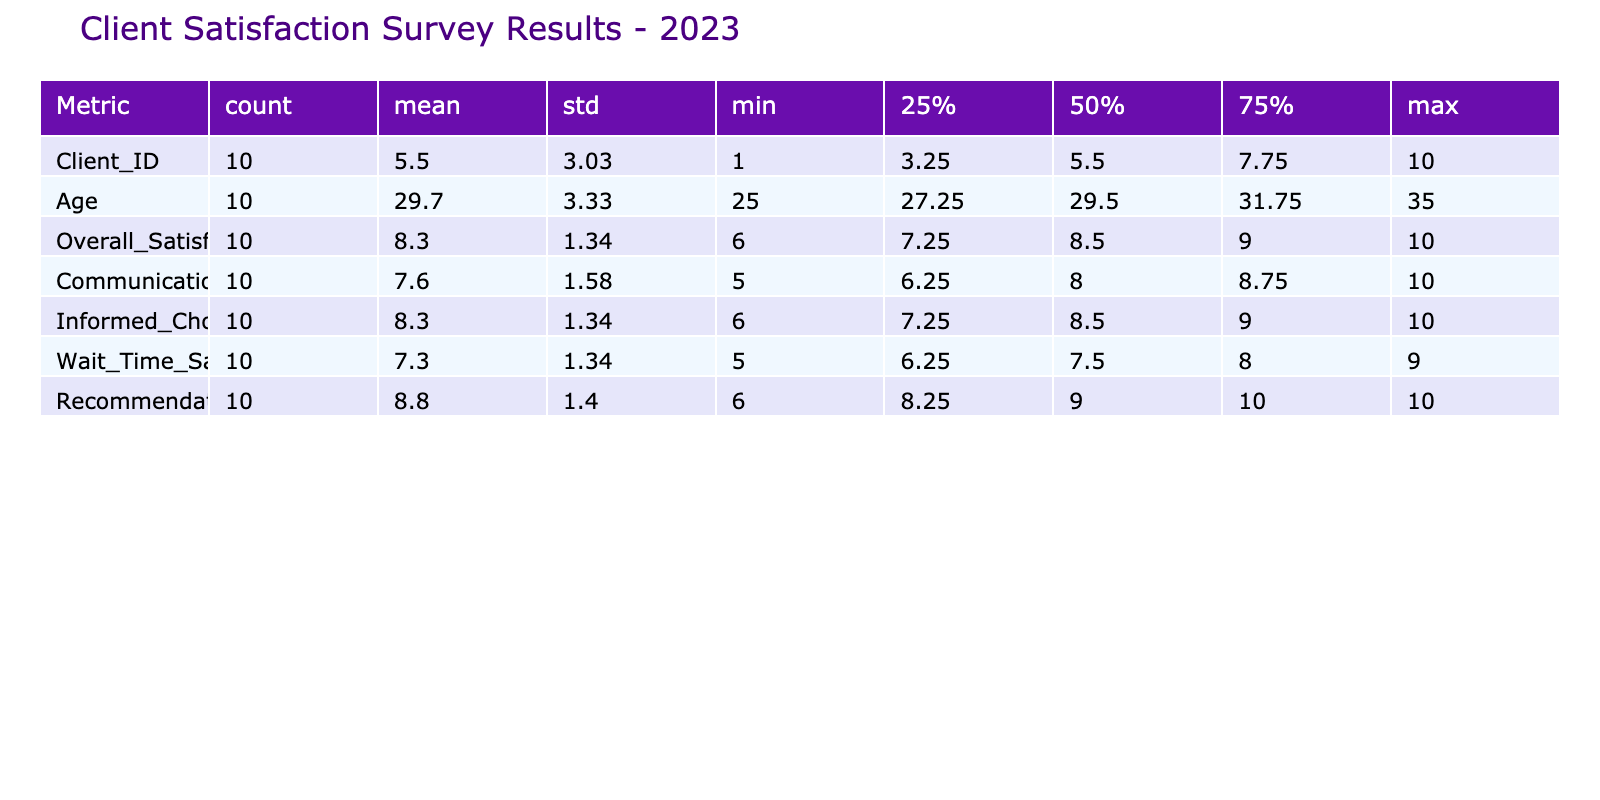What is the overall satisfaction rating for the hospital birth type of care? From the table, we can find the rows for hospital birth. The overall satisfaction ratings are 7, 8, 6, and 7 for each of the four clients who received this type of care. Among these ratings, the highest is 8, while the lowest is 6. The average can be found as (7 + 8 + 6 + 7) / 4 = 7. Thereby, the overall satisfaction rating for hospital births is 7.
Answer: 7 What is the highest communication satisfaction rating recorded in the survey? Looking at the 'Communication Satisfaction' column, the ratings are 8, 6, 9, 7, 8, 9, 5, 10, 8, and 6. The highest rating is 10, which is associated with the client who had a freestanding birth center.
Answer: 10 Can we say that everyone who utilized home birth care would recommend it? By examining the 'Recommendation Likelihood' column for home birth clients, the ratings are 10, 10, 9, 8, and 9. None of the ratings are lower than 8, indicating that all clients who utilized this service would likely recommend it. Therefore, the answer is yes.
Answer: Yes What is the average wait time satisfaction rating across all types of care? The individual ratings for 'Wait Time Satisfaction' are 7, 8, 9, 6, 8, 7, 5, 9, 8, and 6. To calculate the average, we first sum these values: 7 + 8 + 9 + 6 + 8 + 7 + 5 + 9 + 8 + 6 = 79. There are 10 data points, so we divide by 10 to get the average: 79 / 10 = 7.9.
Answer: 7.9 What percentage of clients rated their overall satisfaction higher than 8? Looking at the 'Overall Satisfaction' column, the ratings are 9, 7, 10, 8, 9, 9, 6, 10, 8, and 7. The ratings higher than 8 are 9, 10, 9, 9, and 10, which totals 5 clients. To find the percentage, we divide the number of clients with a rating higher than 8 (5) by the total number of clients (10) and multiply by 100: (5 / 10) * 100 = 50%.
Answer: 50% What is the difference between the highest and lowest recommendation likelihood ratings? From the 'Recommendation Likelihood' column, the ratings are 10, 8, 10, 9, 10, 9, 6, 10, 9, and 7. The highest rating is 10, and the lowest is 6. To find the difference, we subtract the lowest from the highest: 10 - 6 = 4.
Answer: 4 